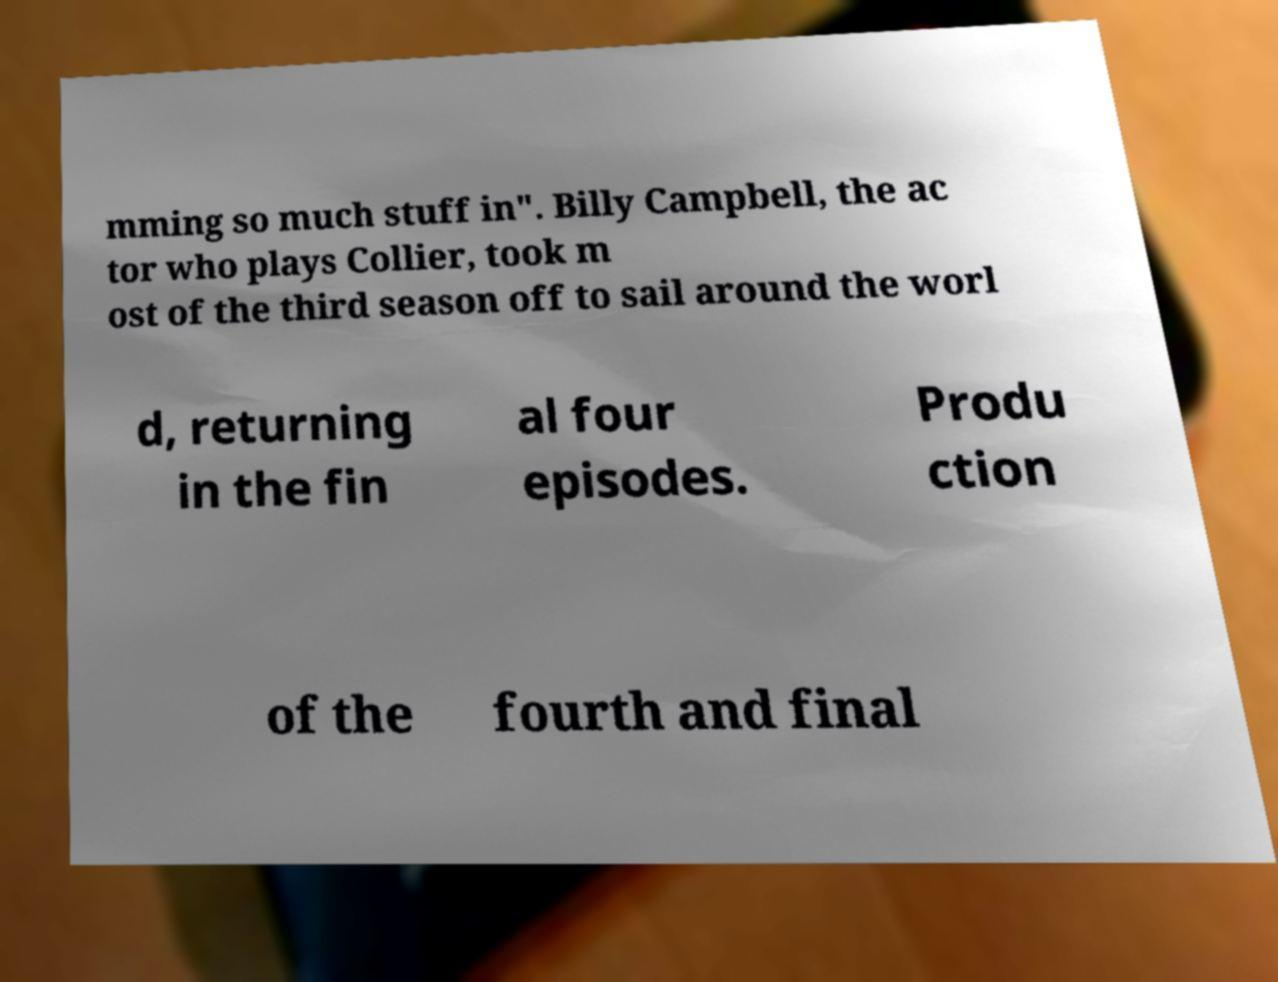Can you accurately transcribe the text from the provided image for me? mming so much stuff in". Billy Campbell, the ac tor who plays Collier, took m ost of the third season off to sail around the worl d, returning in the fin al four episodes. Produ ction of the fourth and final 